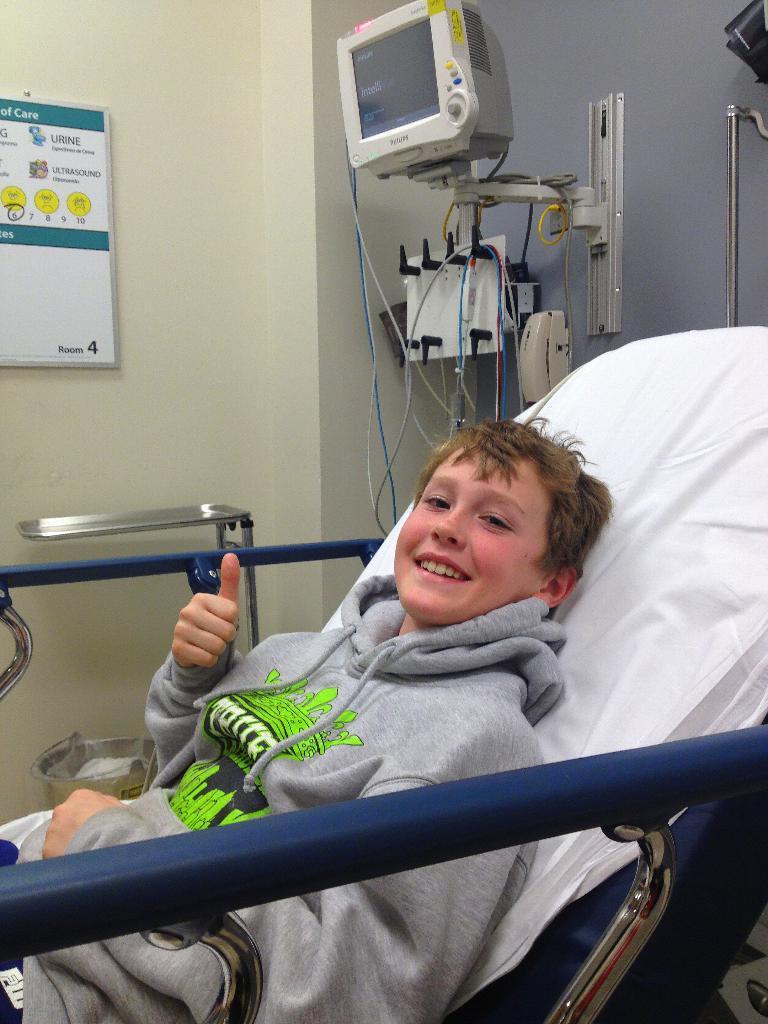How would you summarize this image in a sentence or two? In this image in the front there is a boy laying on the bed and smiling and in the background there is a monitor on the stand and there are instruments and there is a board on the wall with some text written on it. 